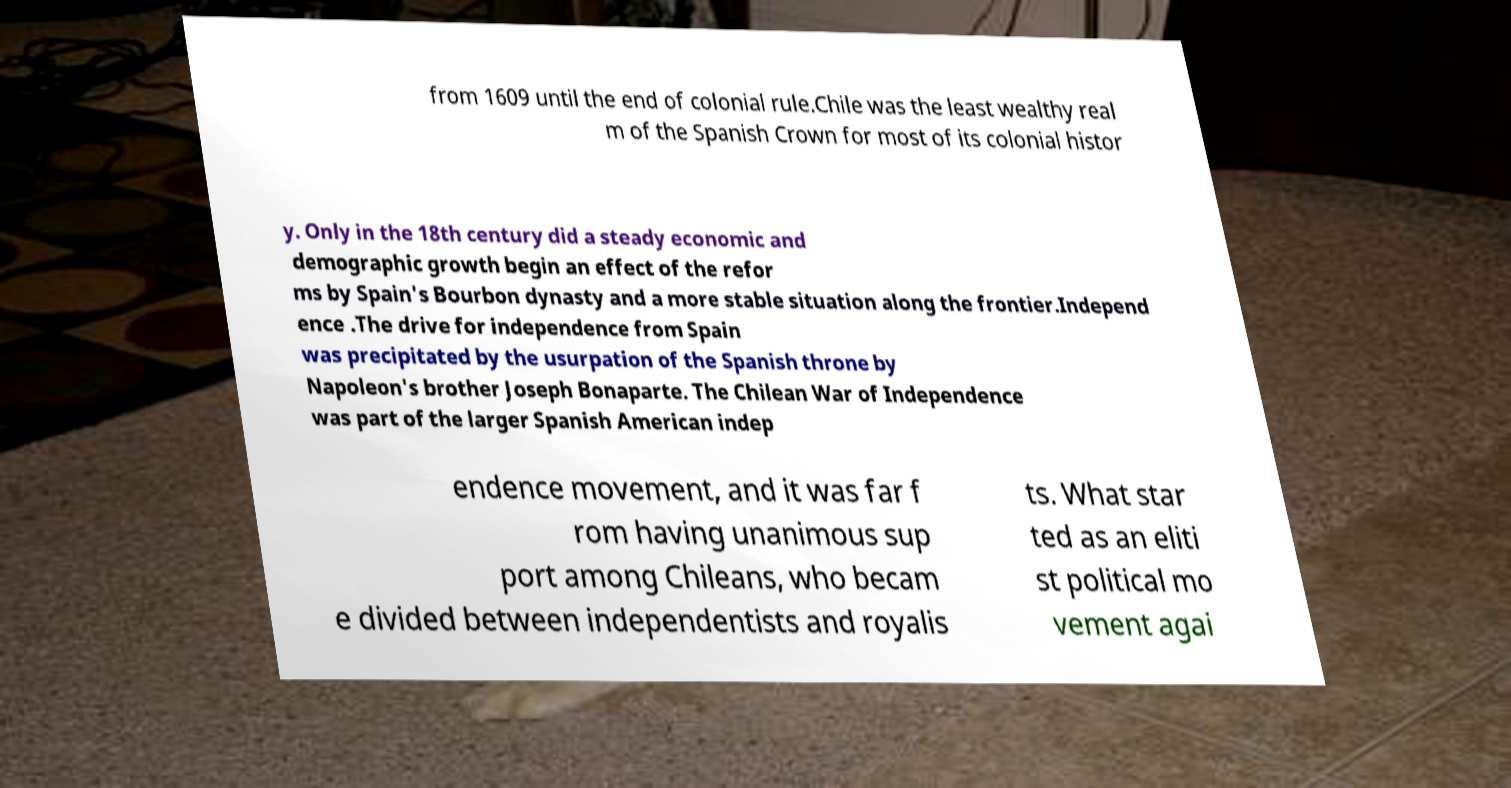Can you accurately transcribe the text from the provided image for me? from 1609 until the end of colonial rule.Chile was the least wealthy real m of the Spanish Crown for most of its colonial histor y. Only in the 18th century did a steady economic and demographic growth begin an effect of the refor ms by Spain's Bourbon dynasty and a more stable situation along the frontier.Independ ence .The drive for independence from Spain was precipitated by the usurpation of the Spanish throne by Napoleon's brother Joseph Bonaparte. The Chilean War of Independence was part of the larger Spanish American indep endence movement, and it was far f rom having unanimous sup port among Chileans, who becam e divided between independentists and royalis ts. What star ted as an eliti st political mo vement agai 